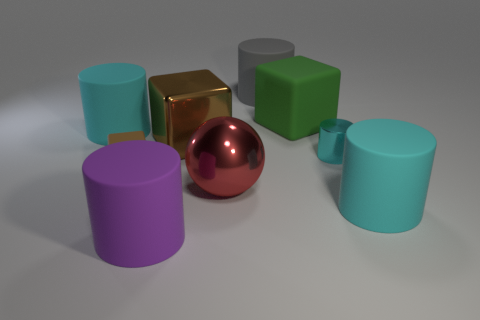Subtract all green matte blocks. How many blocks are left? 2 Add 1 tiny gray cylinders. How many objects exist? 10 Subtract all gray cylinders. How many cylinders are left? 4 Subtract all cylinders. How many objects are left? 4 Subtract 5 cylinders. How many cylinders are left? 0 Subtract all cyan rubber things. Subtract all large green matte objects. How many objects are left? 6 Add 6 large blocks. How many large blocks are left? 8 Add 6 green metal balls. How many green metal balls exist? 6 Subtract 0 purple spheres. How many objects are left? 9 Subtract all red blocks. Subtract all gray cylinders. How many blocks are left? 3 